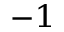<formula> <loc_0><loc_0><loc_500><loc_500>^ { - 1 }</formula> 